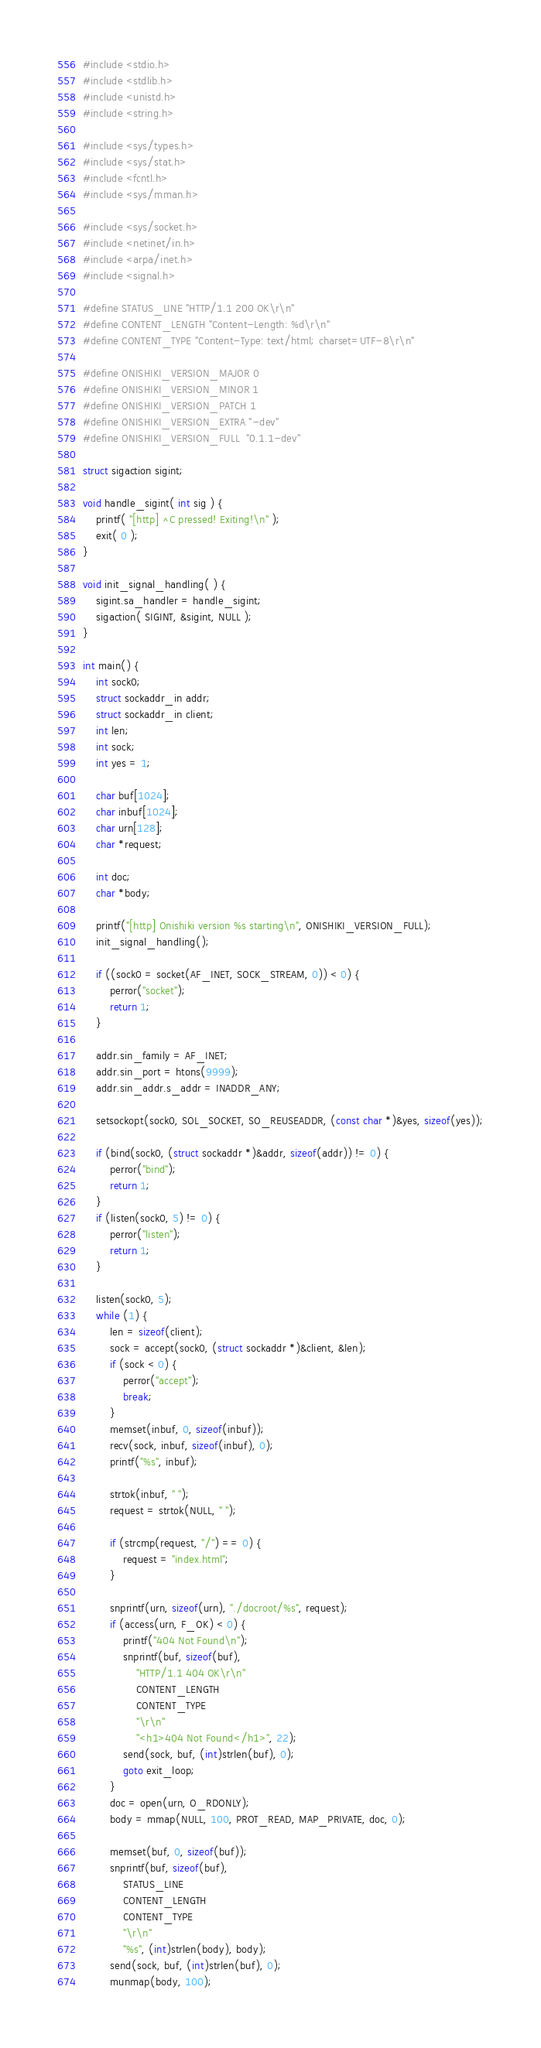<code> <loc_0><loc_0><loc_500><loc_500><_C_>#include <stdio.h>
#include <stdlib.h>
#include <unistd.h>
#include <string.h>

#include <sys/types.h>
#include <sys/stat.h>
#include <fcntl.h>
#include <sys/mman.h>

#include <sys/socket.h>
#include <netinet/in.h>
#include <arpa/inet.h>
#include <signal.h>

#define STATUS_LINE "HTTP/1.1 200 OK\r\n"
#define CONTENT_LENGTH "Content-Length: %d\r\n"
#define CONTENT_TYPE "Content-Type: text/html; charset=UTF-8\r\n"

#define ONISHIKI_VERSION_MAJOR 0
#define ONISHIKI_VERSION_MINOR 1
#define ONISHIKI_VERSION_PATCH 1
#define ONISHIKI_VERSION_EXTRA "-dev"
#define ONISHIKI_VERSION_FULL  "0.1.1-dev"

struct sigaction sigint;

void handle_sigint( int sig ) {
	printf( "[http] ^C pressed! Exiting!\n" );
	exit( 0 );
}

void init_signal_handling( ) {
	sigint.sa_handler = handle_sigint;
	sigaction( SIGINT, &sigint, NULL );
}

int main() {
    int sock0;
	struct sockaddr_in addr;
	struct sockaddr_in client;
	int len;
	int sock;
	int yes = 1;

	char buf[1024];
	char inbuf[1024];
	char urn[128];
	char *request;
	
	int doc;
    char *body;

	printf("[http] Onishiki version %s starting\n", ONISHIKI_VERSION_FULL);
	init_signal_handling();

	if ((sock0 = socket(AF_INET, SOCK_STREAM, 0)) < 0) {
		perror("socket");
		return 1;
	}

    addr.sin_family = AF_INET;
	addr.sin_port = htons(9999);
	addr.sin_addr.s_addr = INADDR_ANY;

	setsockopt(sock0, SOL_SOCKET, SO_REUSEADDR, (const char *)&yes, sizeof(yes));

	if (bind(sock0, (struct sockaddr *)&addr, sizeof(addr)) != 0) {
		perror("bind");
		return 1;
	}
	if (listen(sock0, 5) != 0) {
		perror("listen");
		return 1;
	}

    listen(sock0, 5);
	while (1) {
		len = sizeof(client);
		sock = accept(sock0, (struct sockaddr *)&client, &len);
		if (sock < 0) {
			perror("accept");
			break;
		}
		memset(inbuf, 0, sizeof(inbuf));
		recv(sock, inbuf, sizeof(inbuf), 0);
		printf("%s", inbuf);

		strtok(inbuf, " ");
		request = strtok(NULL, " ");

		if (strcmp(request, "/") == 0) {
			request = "index.html";
		}

        snprintf(urn, sizeof(urn), "./docroot/%s", request);
		if (access(urn, F_OK) < 0) {
			printf("404 Not Found\n");
			snprintf(buf, sizeof(buf),
			    "HTTP/1.1 404 OK\r\n"
			    CONTENT_LENGTH
			    CONTENT_TYPE
			    "\r\n"
			    "<h1>404 Not Found</h1>", 22);
			send(sock, buf, (int)strlen(buf), 0);
			goto exit_loop;
		}
		doc = open(urn, O_RDONLY);
		body = mmap(NULL, 100, PROT_READ, MAP_PRIVATE, doc, 0);

        memset(buf, 0, sizeof(buf));
		snprintf(buf, sizeof(buf),
		    STATUS_LINE
		    CONTENT_LENGTH
		    CONTENT_TYPE
		    "\r\n"
		    "%s", (int)strlen(body), body);
		send(sock, buf, (int)strlen(buf), 0);
		munmap(body, 100);
</code> 